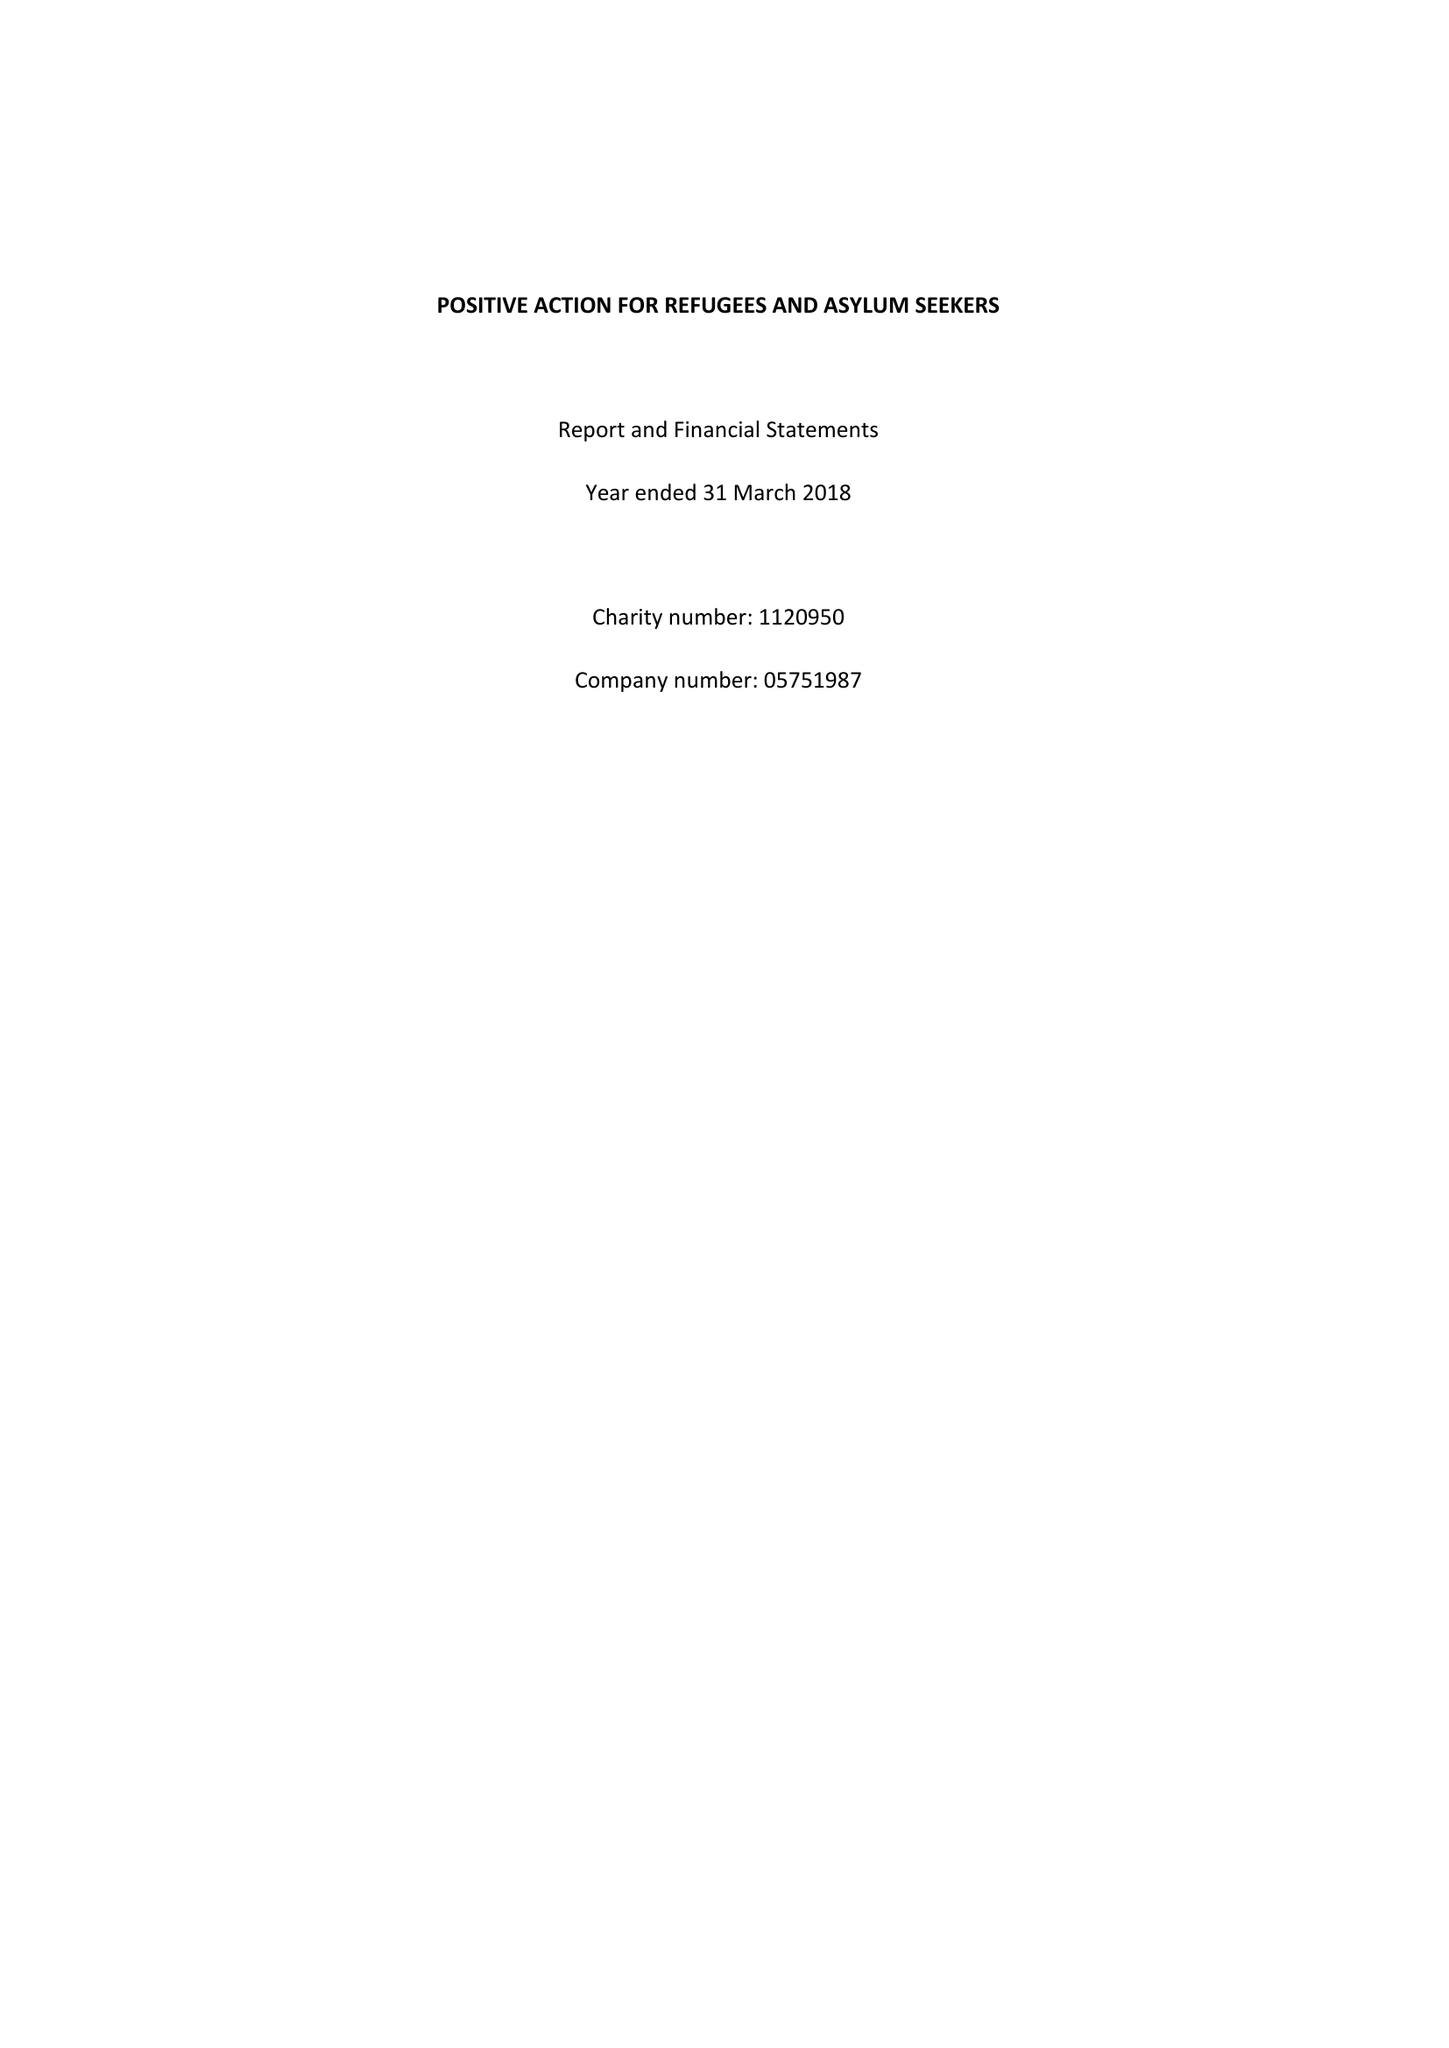What is the value for the charity_name?
Answer the question using a single word or phrase. Positive Action For Refugees and Asylum Seekers 